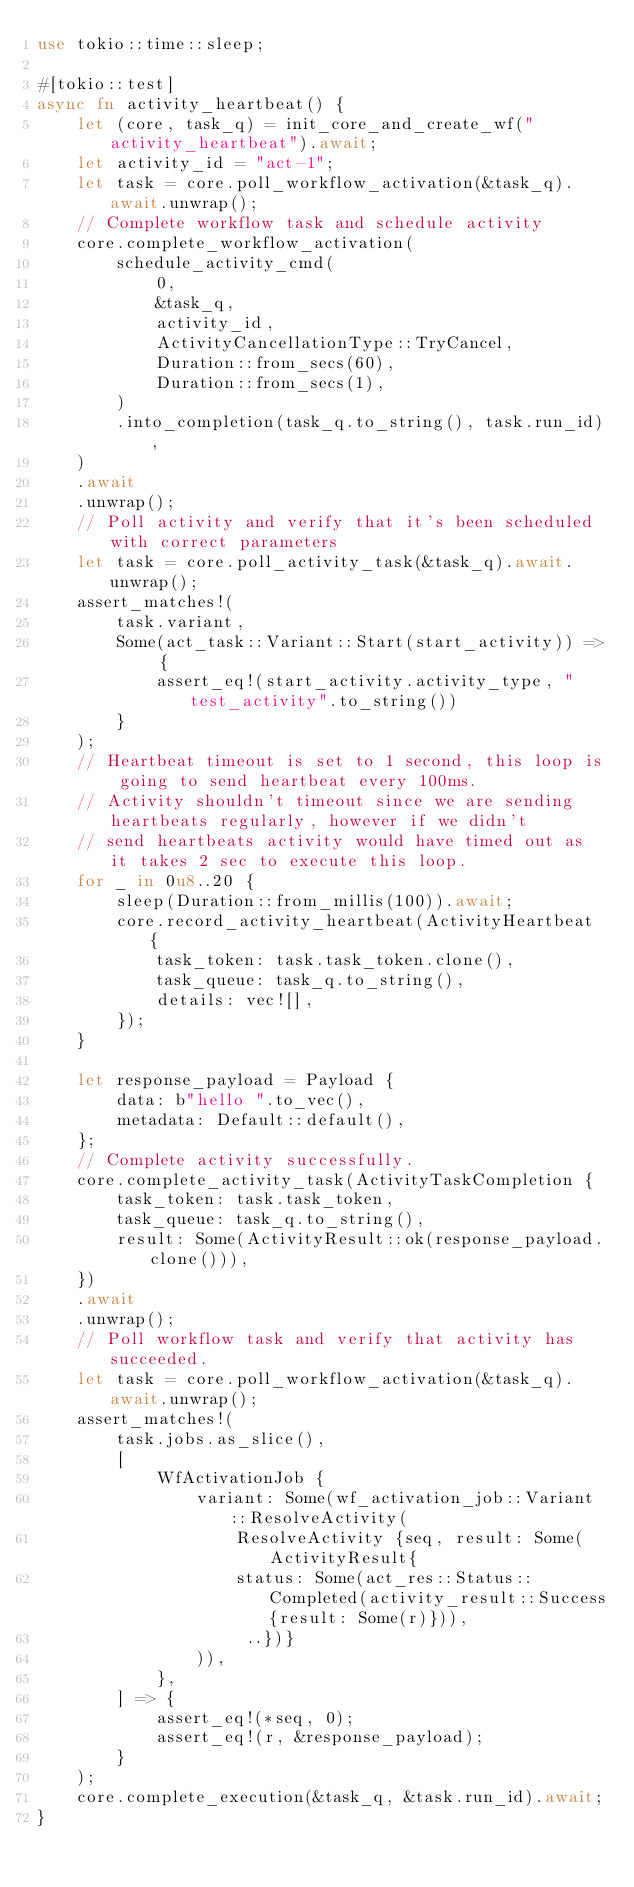Convert code to text. <code><loc_0><loc_0><loc_500><loc_500><_Rust_>use tokio::time::sleep;

#[tokio::test]
async fn activity_heartbeat() {
    let (core, task_q) = init_core_and_create_wf("activity_heartbeat").await;
    let activity_id = "act-1";
    let task = core.poll_workflow_activation(&task_q).await.unwrap();
    // Complete workflow task and schedule activity
    core.complete_workflow_activation(
        schedule_activity_cmd(
            0,
            &task_q,
            activity_id,
            ActivityCancellationType::TryCancel,
            Duration::from_secs(60),
            Duration::from_secs(1),
        )
        .into_completion(task_q.to_string(), task.run_id),
    )
    .await
    .unwrap();
    // Poll activity and verify that it's been scheduled with correct parameters
    let task = core.poll_activity_task(&task_q).await.unwrap();
    assert_matches!(
        task.variant,
        Some(act_task::Variant::Start(start_activity)) => {
            assert_eq!(start_activity.activity_type, "test_activity".to_string())
        }
    );
    // Heartbeat timeout is set to 1 second, this loop is going to send heartbeat every 100ms.
    // Activity shouldn't timeout since we are sending heartbeats regularly, however if we didn't
    // send heartbeats activity would have timed out as it takes 2 sec to execute this loop.
    for _ in 0u8..20 {
        sleep(Duration::from_millis(100)).await;
        core.record_activity_heartbeat(ActivityHeartbeat {
            task_token: task.task_token.clone(),
            task_queue: task_q.to_string(),
            details: vec![],
        });
    }

    let response_payload = Payload {
        data: b"hello ".to_vec(),
        metadata: Default::default(),
    };
    // Complete activity successfully.
    core.complete_activity_task(ActivityTaskCompletion {
        task_token: task.task_token,
        task_queue: task_q.to_string(),
        result: Some(ActivityResult::ok(response_payload.clone())),
    })
    .await
    .unwrap();
    // Poll workflow task and verify that activity has succeeded.
    let task = core.poll_workflow_activation(&task_q).await.unwrap();
    assert_matches!(
        task.jobs.as_slice(),
        [
            WfActivationJob {
                variant: Some(wf_activation_job::Variant::ResolveActivity(
                    ResolveActivity {seq, result: Some(ActivityResult{
                    status: Some(act_res::Status::Completed(activity_result::Success{result: Some(r)})),
                     ..})}
                )),
            },
        ] => {
            assert_eq!(*seq, 0);
            assert_eq!(r, &response_payload);
        }
    );
    core.complete_execution(&task_q, &task.run_id).await;
}
</code> 